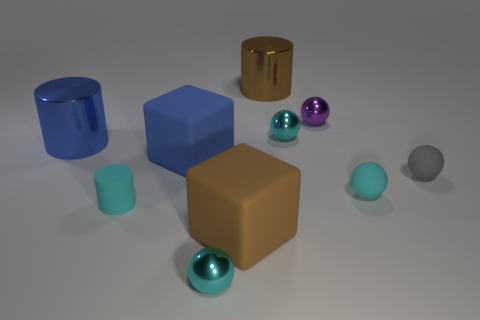What is the material of the large cylinder that is on the right side of the cyan metallic thing in front of the matte cube to the right of the large blue block? The large cylinder on the right side of the cyan metallic object appears to be made of a reflective, possibly metallic material, similar in sheen to the other objects around it, suggesting a composition of either polished metal or a metal-like synthetic. 